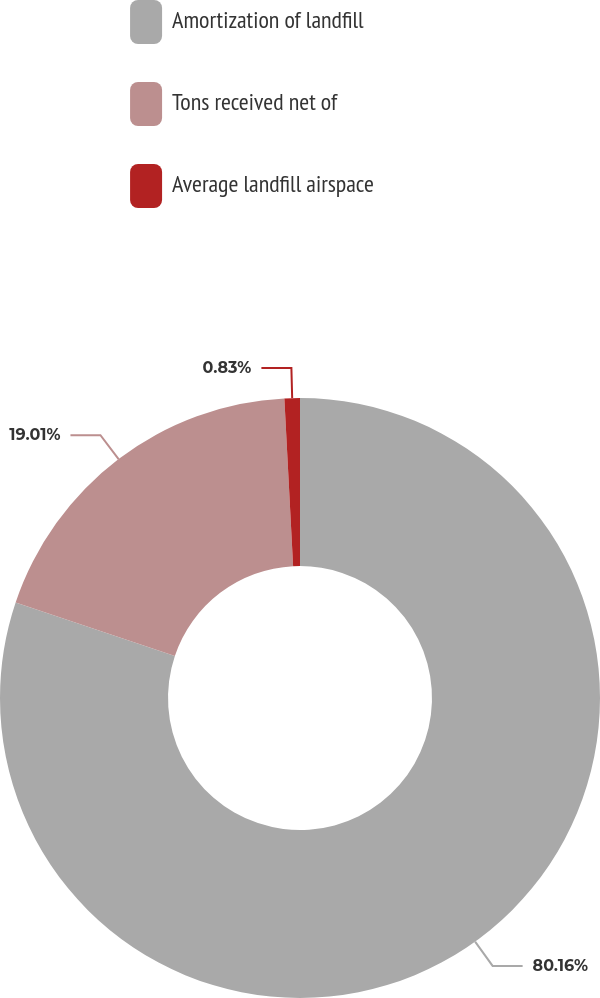Convert chart to OTSL. <chart><loc_0><loc_0><loc_500><loc_500><pie_chart><fcel>Amortization of landfill<fcel>Tons received net of<fcel>Average landfill airspace<nl><fcel>80.16%<fcel>19.01%<fcel>0.83%<nl></chart> 